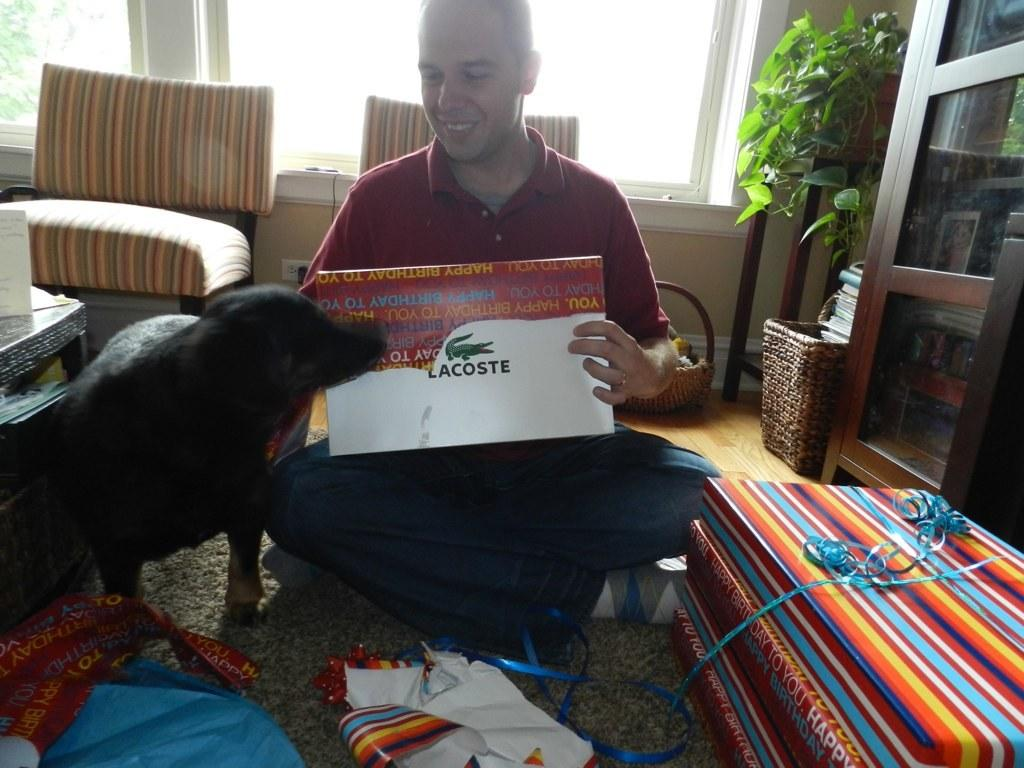What is the man in the image doing? The man is sitting and opening gift packs in the image. Can you describe the presence of an animal in the image? Yes, there is a dog beside the man in the image. What type of furniture is present in the image? There is a table and two sofa chairs in the image. Are there any plants visible in the image? Yes, there is a house plant in the image. What else can be seen on the table besides the gift packs? There are no other items visible on the table besides the gift packs. What type of storage units are present in the image? There are cupboards in the image. What type of yarn is the man using to knit a sweater in the image? There is no yarn or knitting activity present in the image; the man is opening gift packs. Can you provide an example of a gift pack that the man is opening in the image? The image does not provide a close-up view of the gift packs, so it is not possible to describe the contents of a specific gift pack. 